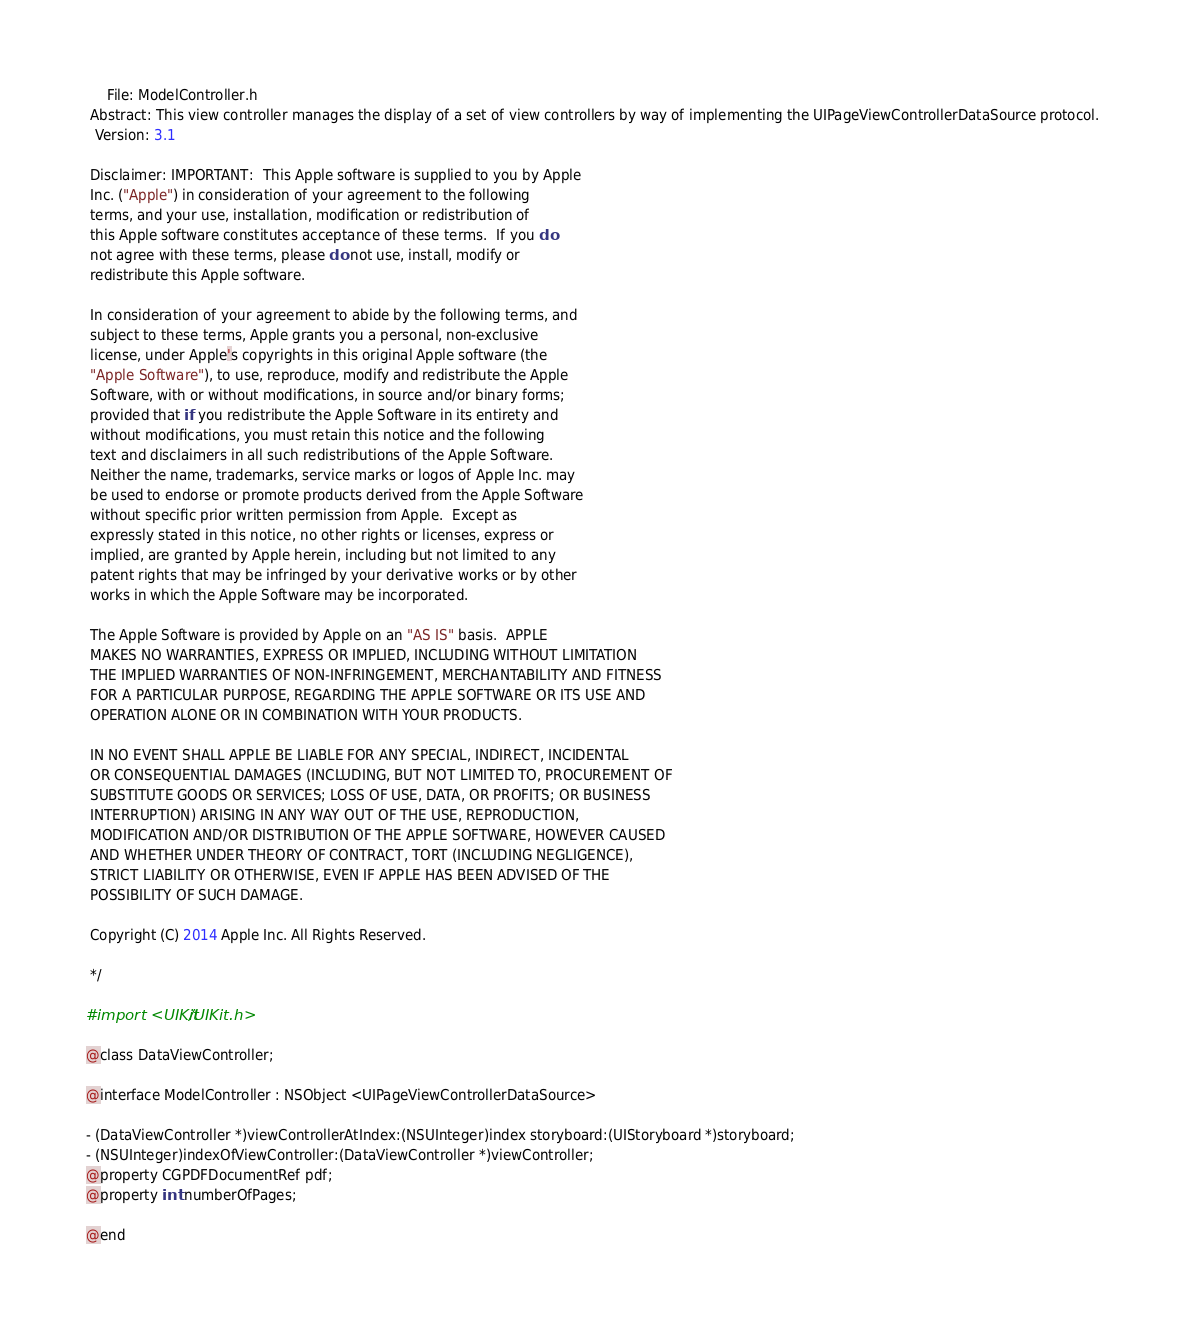<code> <loc_0><loc_0><loc_500><loc_500><_C_>     File: ModelController.h
 Abstract: This view controller manages the display of a set of view controllers by way of implementing the UIPageViewControllerDataSource protocol.
  Version: 3.1
 
 Disclaimer: IMPORTANT:  This Apple software is supplied to you by Apple
 Inc. ("Apple") in consideration of your agreement to the following
 terms, and your use, installation, modification or redistribution of
 this Apple software constitutes acceptance of these terms.  If you do
 not agree with these terms, please do not use, install, modify or
 redistribute this Apple software.
 
 In consideration of your agreement to abide by the following terms, and
 subject to these terms, Apple grants you a personal, non-exclusive
 license, under Apple's copyrights in this original Apple software (the
 "Apple Software"), to use, reproduce, modify and redistribute the Apple
 Software, with or without modifications, in source and/or binary forms;
 provided that if you redistribute the Apple Software in its entirety and
 without modifications, you must retain this notice and the following
 text and disclaimers in all such redistributions of the Apple Software.
 Neither the name, trademarks, service marks or logos of Apple Inc. may
 be used to endorse or promote products derived from the Apple Software
 without specific prior written permission from Apple.  Except as
 expressly stated in this notice, no other rights or licenses, express or
 implied, are granted by Apple herein, including but not limited to any
 patent rights that may be infringed by your derivative works or by other
 works in which the Apple Software may be incorporated.
 
 The Apple Software is provided by Apple on an "AS IS" basis.  APPLE
 MAKES NO WARRANTIES, EXPRESS OR IMPLIED, INCLUDING WITHOUT LIMITATION
 THE IMPLIED WARRANTIES OF NON-INFRINGEMENT, MERCHANTABILITY AND FITNESS
 FOR A PARTICULAR PURPOSE, REGARDING THE APPLE SOFTWARE OR ITS USE AND
 OPERATION ALONE OR IN COMBINATION WITH YOUR PRODUCTS.
 
 IN NO EVENT SHALL APPLE BE LIABLE FOR ANY SPECIAL, INDIRECT, INCIDENTAL
 OR CONSEQUENTIAL DAMAGES (INCLUDING, BUT NOT LIMITED TO, PROCUREMENT OF
 SUBSTITUTE GOODS OR SERVICES; LOSS OF USE, DATA, OR PROFITS; OR BUSINESS
 INTERRUPTION) ARISING IN ANY WAY OUT OF THE USE, REPRODUCTION,
 MODIFICATION AND/OR DISTRIBUTION OF THE APPLE SOFTWARE, HOWEVER CAUSED
 AND WHETHER UNDER THEORY OF CONTRACT, TORT (INCLUDING NEGLIGENCE),
 STRICT LIABILITY OR OTHERWISE, EVEN IF APPLE HAS BEEN ADVISED OF THE
 POSSIBILITY OF SUCH DAMAGE.
 
 Copyright (C) 2014 Apple Inc. All Rights Reserved.
 
 */

#import <UIKit/UIKit.h>

@class DataViewController;

@interface ModelController : NSObject <UIPageViewControllerDataSource>

- (DataViewController *)viewControllerAtIndex:(NSUInteger)index storyboard:(UIStoryboard *)storyboard;
- (NSUInteger)indexOfViewController:(DataViewController *)viewController;
@property CGPDFDocumentRef pdf;
@property int numberOfPages; 

@end
</code> 